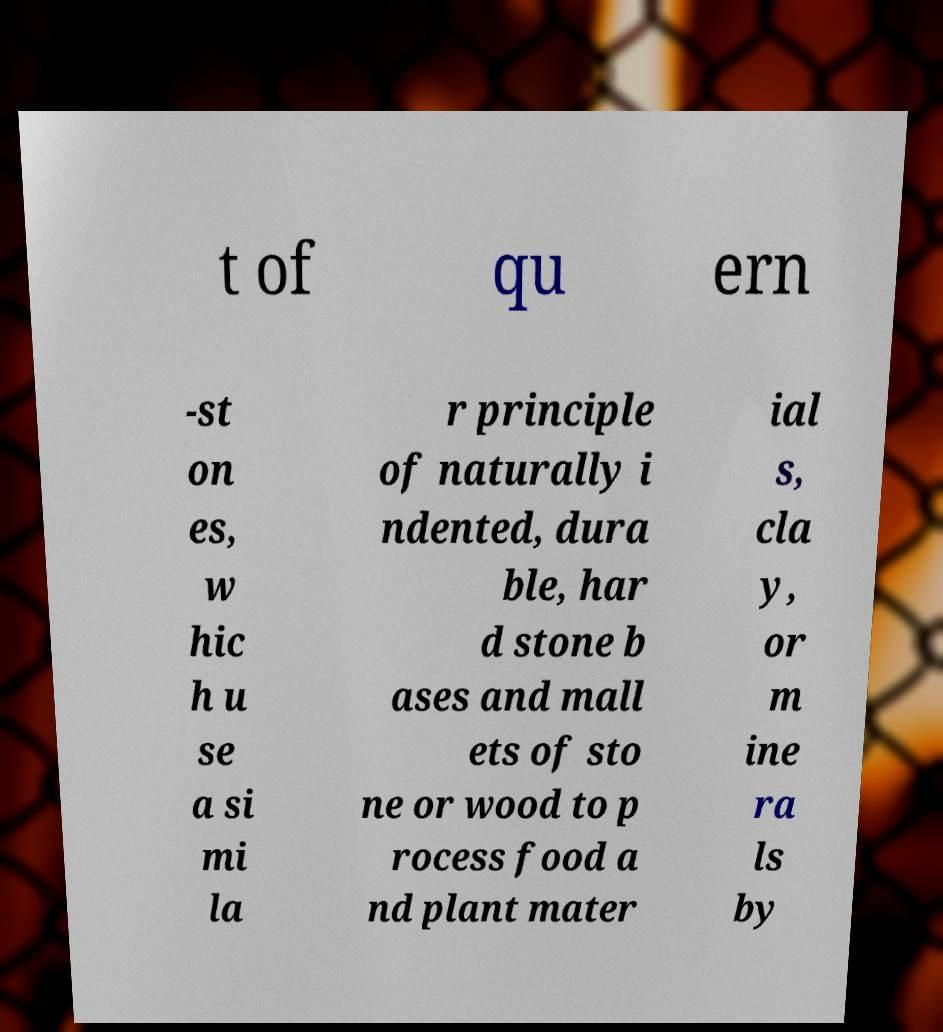What messages or text are displayed in this image? I need them in a readable, typed format. t of qu ern -st on es, w hic h u se a si mi la r principle of naturally i ndented, dura ble, har d stone b ases and mall ets of sto ne or wood to p rocess food a nd plant mater ial s, cla y, or m ine ra ls by 